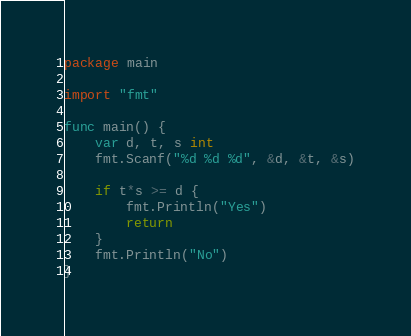<code> <loc_0><loc_0><loc_500><loc_500><_Go_>package main

import "fmt"

func main() {
	var d, t, s int
	fmt.Scanf("%d %d %d", &d, &t, &s)

	if t*s >= d {
		fmt.Println("Yes")
		return
	}
	fmt.Println("No")
}
</code> 